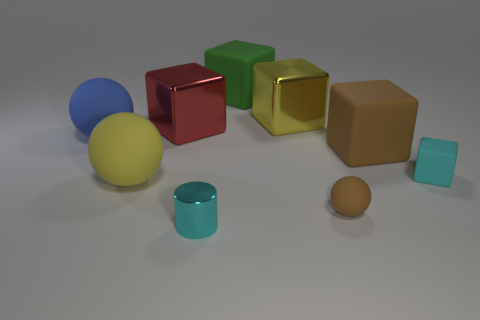There is a small matte object that is on the right side of the small brown thing; what color is it?
Make the answer very short. Cyan. There is a brown rubber thing that is in front of the big yellow ball; is it the same size as the yellow thing on the right side of the small cyan cylinder?
Ensure brevity in your answer.  No. Is there a brown metallic ball of the same size as the red metal block?
Offer a terse response. No. What number of tiny matte things are behind the big yellow thing on the left side of the large green cube?
Your response must be concise. 1. What material is the large red cube?
Your answer should be very brief. Metal. What number of shiny cubes are left of the big yellow block?
Provide a succinct answer. 1. Is the color of the metal cylinder the same as the small matte ball?
Provide a short and direct response. No. What number of small matte objects are the same color as the small rubber sphere?
Offer a very short reply. 0. Are there more big brown rubber cylinders than big yellow spheres?
Offer a terse response. No. There is a rubber sphere that is in front of the large blue rubber ball and to the left of the tiny ball; what size is it?
Give a very brief answer. Large. 